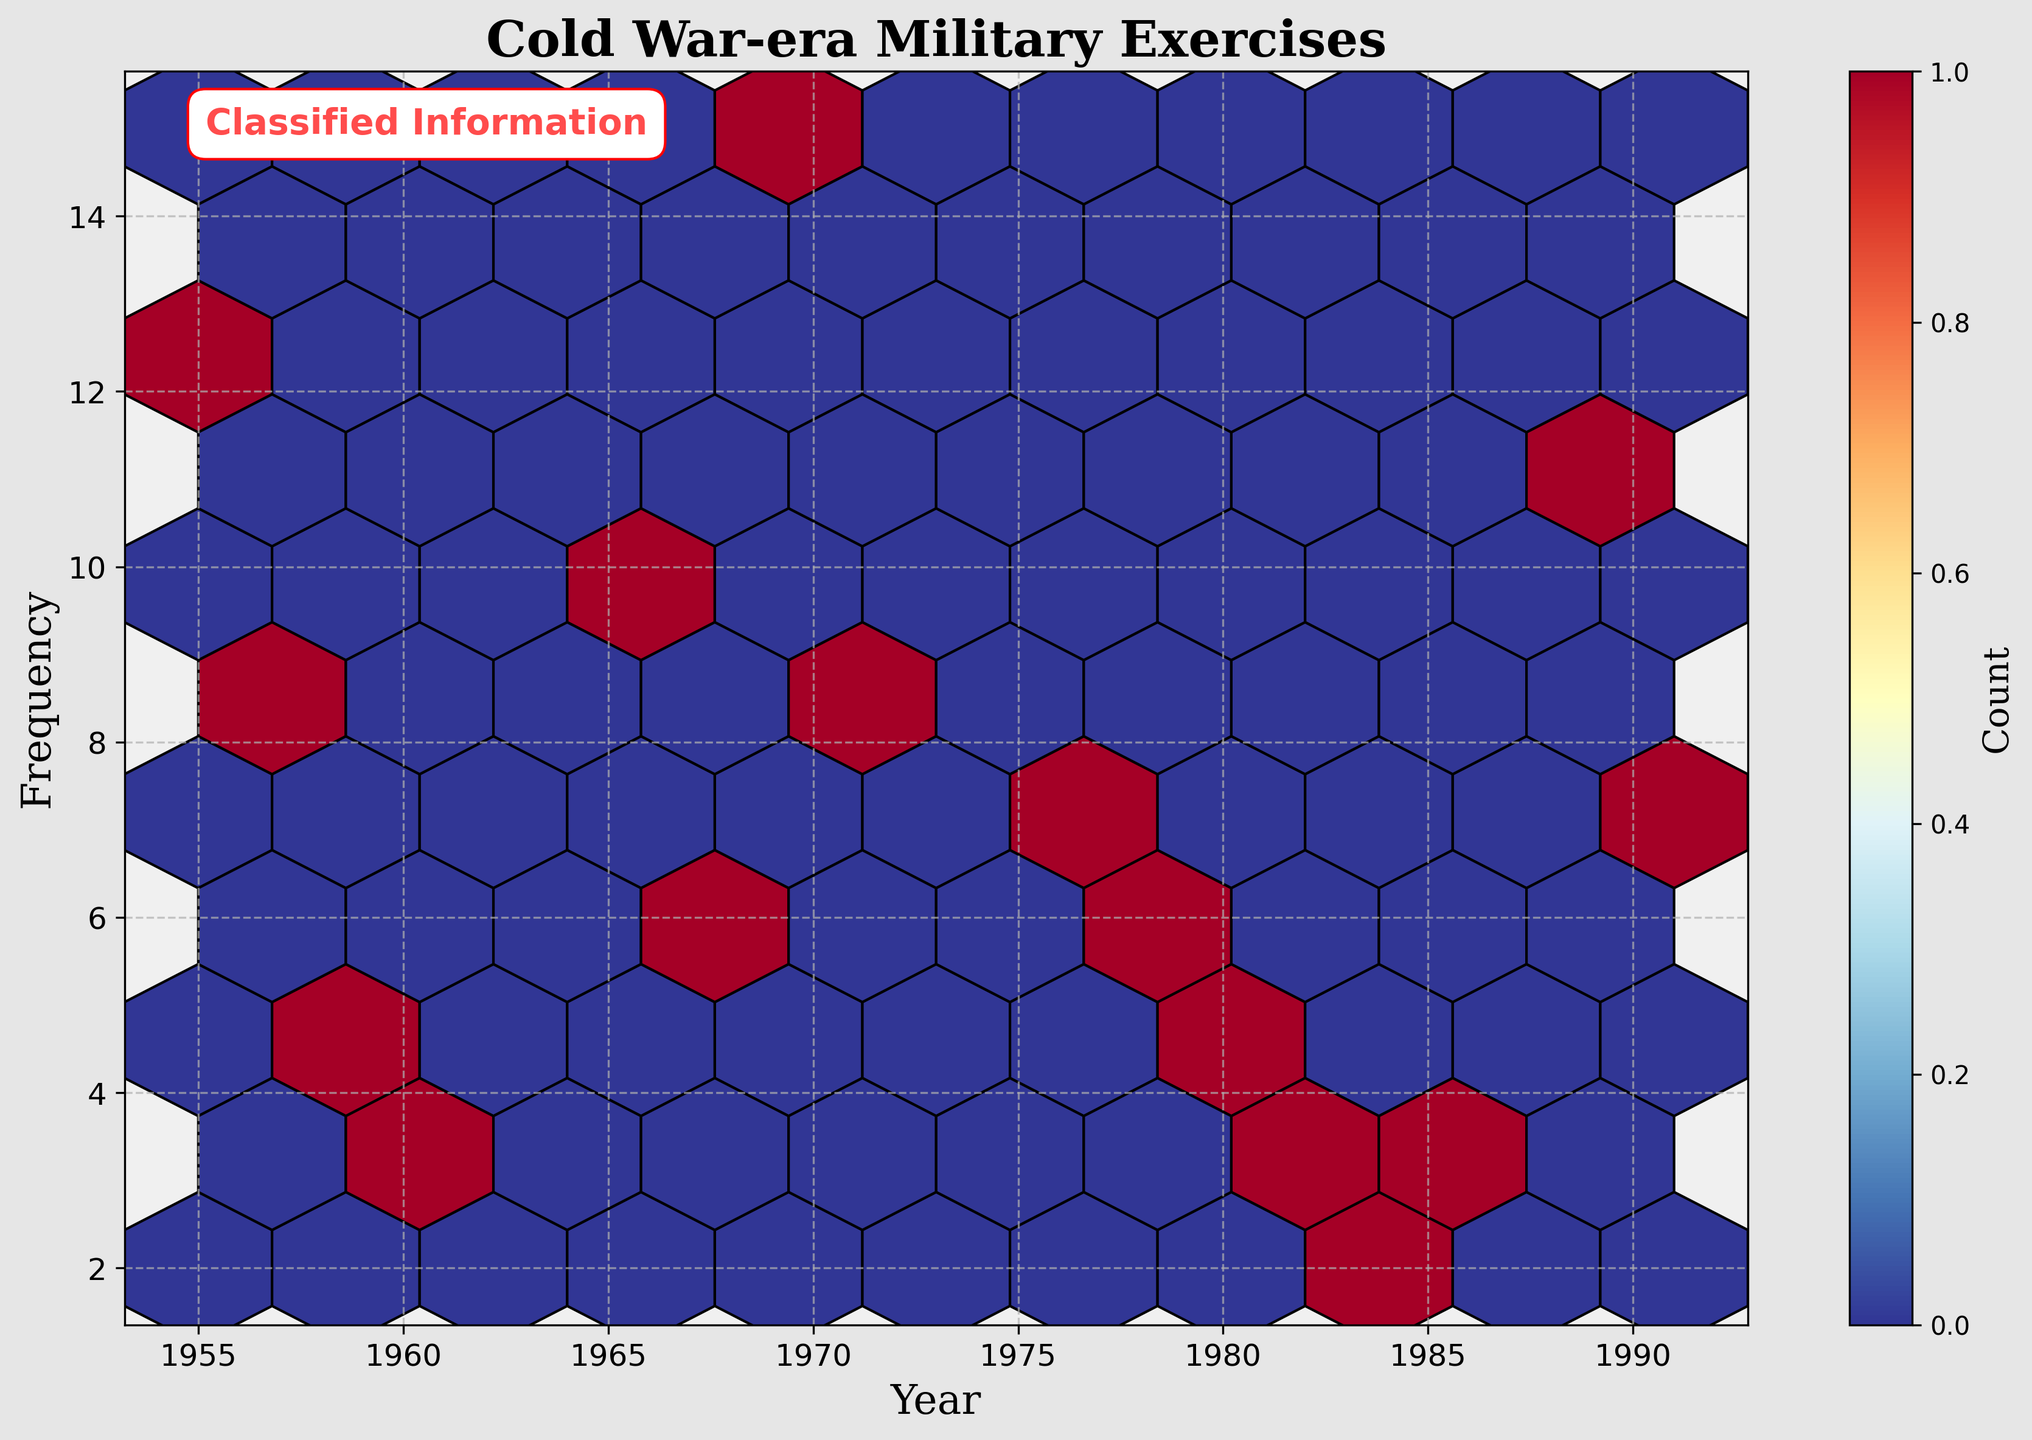What is the title of the plot? The title is displayed at the top of the figure to provide a brief description of what the plot represents.
Answer: Cold War-era Military Exercises What are the labels for the axes? Axis labels provide information on what each axis represents, helping us understand the data dimensions. The x-axis label is "Year," and the y-axis label is "Frequency."
Answer: Year and Frequency Which year had the highest frequency of exercises? To determine this, we look for the hexagons with the highest color intensity (representing higher counts) and check their position on the x-axis.
Answer: 1970 How many regions had a frequency of exactly 10 exercises? This requires checking the plot for the hexagon that corresponds to a frequency of 10 on the y-axis and counting those regions.
Answer: One What can you infer about the general trend in the frequency of military exercises over time? Observing the density and spread of the hexagons over the years on the x-axis, we can infer patterns or trends in the data. There is a visible clustering around certain time periods indicating fluctuation.
Answer: It fluctuates with peaks around 1970 and 1989 Which decade had the most diverse frequency of exercises? Analyzing the distribution of hexagons by decade, the one with a wider spread of data points on the y-axis indicates diversity in frequency. The 1980s was the most diverse decade since it ranges from 2 to 11 exercises.
Answer: 1980s Did any of the regions have periods with very sparse military exercises? This can be inferred from parts of the plot with few or no hexagons, indicating sparse or no data points for certain periods. The Arctic and Angola had very sparse contributions.
Answer: Yes Which year (among the plotted) had the lowest frequency of military exercises? Identifying the year with the lowest frequency involves finding the lowest y-axis value in the plot.
Answer: 1985 Is there a specific region that consistently had high frequencies over many years? By examining the clusters and repeated high-intensity hexagons, we can determine if any region appears frequently with higher counts.
Answer: Eastern Europe consistently had high frequencies What is the color distribution revealing about the density of exercises across the years? Different colors in the hexbin plot represent varying frequencies. By observing the color scale, which transitions from blue to red, one can infer the density of military exercises over time.
Answer: Higher densities in the '70s and '80s 